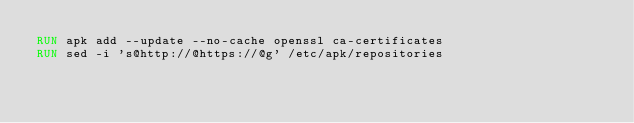Convert code to text. <code><loc_0><loc_0><loc_500><loc_500><_Dockerfile_>RUN apk add --update --no-cache openssl ca-certificates
RUN sed -i 's@http://@https://@g' /etc/apk/repositories
</code> 